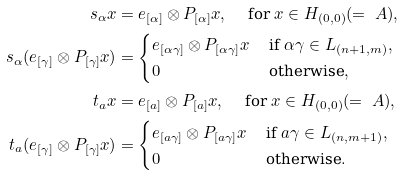Convert formula to latex. <formula><loc_0><loc_0><loc_500><loc_500>s _ { \alpha } x & = e _ { [ \alpha ] } \otimes P _ { [ \alpha ] } x , \quad \text { for } x \in H _ { ( 0 , 0 ) } ( = \ A ) , \\ s _ { \alpha } ( e _ { [ \gamma ] } \otimes P _ { [ \gamma ] } x ) & = { \begin{cases} e _ { [ \alpha \gamma ] } \otimes P _ { [ \alpha \gamma ] } x & \text { if } \alpha \gamma \in L _ { ( n + 1 , m ) } , \\ 0 & \text { otherwise} , \end{cases} } \\ t _ { a } x & = e _ { [ a ] } \otimes P _ { [ a ] } x , \quad \text { for } x \in H _ { ( 0 , 0 ) } ( = \ A ) , \\ t _ { a } ( e _ { [ \gamma ] } \otimes P _ { [ \gamma ] } x ) & = { \begin{cases} e _ { [ a \gamma ] } \otimes P _ { [ a \gamma ] } x & \text { if } a \gamma \in L _ { ( n , m + 1 ) } , \\ 0 & \text { otherwise} . \end{cases} }</formula> 